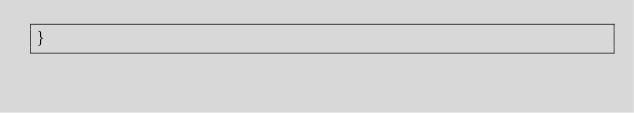<code> <loc_0><loc_0><loc_500><loc_500><_Kotlin_>}
</code> 